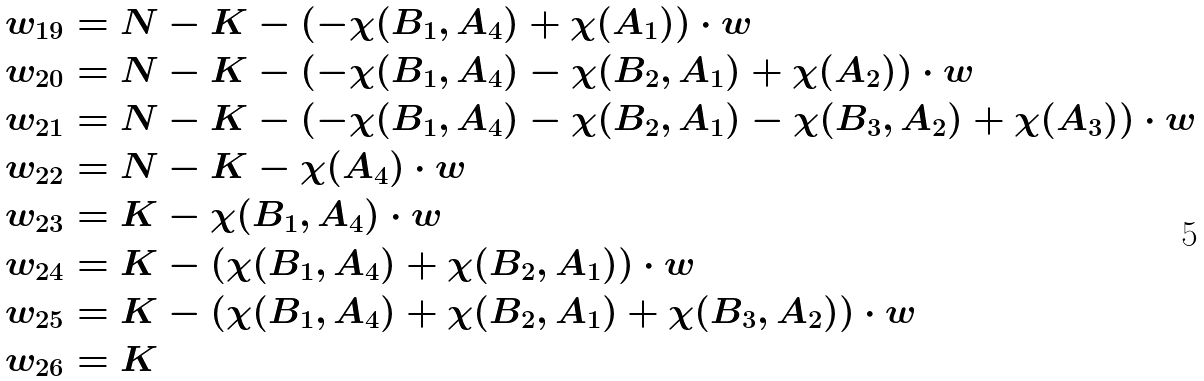<formula> <loc_0><loc_0><loc_500><loc_500>w _ { 1 9 } & = N - K - ( - \chi ( B _ { 1 } , A _ { 4 } ) + \chi ( A _ { 1 } ) ) \cdot { w } \\ w _ { 2 0 } & = N - K - ( - \chi ( B _ { 1 } , A _ { 4 } ) - \chi ( B _ { 2 } , A _ { 1 } ) + \chi ( A _ { 2 } ) ) \cdot { w } \\ w _ { 2 1 } & = N - K - ( - \chi ( B _ { 1 } , A _ { 4 } ) - \chi ( B _ { 2 } , A _ { 1 } ) - \chi ( B _ { 3 } , A _ { 2 } ) + \chi ( A _ { 3 } ) ) \cdot { w } \\ w _ { 2 2 } & = N - K - \chi ( A _ { 4 } ) \cdot { w } \\ w _ { 2 3 } & = K - \chi ( B _ { 1 } , A _ { 4 } ) \cdot { w } \\ w _ { 2 4 } & = K - ( \chi ( B _ { 1 } , A _ { 4 } ) + \chi ( B _ { 2 } , A _ { 1 } ) ) \cdot { w } \\ w _ { 2 5 } & = K - ( \chi ( B _ { 1 } , A _ { 4 } ) + \chi ( B _ { 2 } , A _ { 1 } ) + \chi ( B _ { 3 } , A _ { 2 } ) ) \cdot { w } \\ w _ { 2 6 } & = K</formula> 